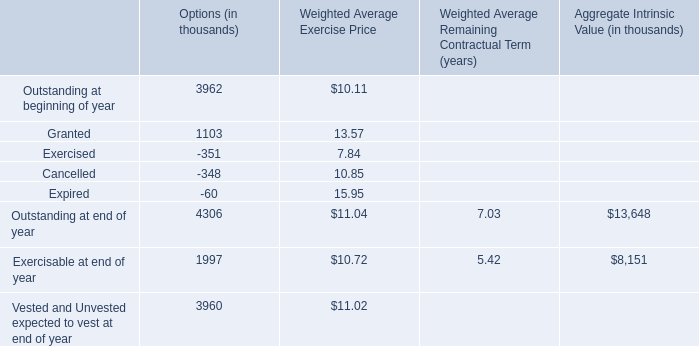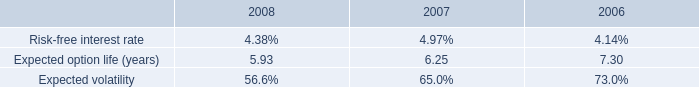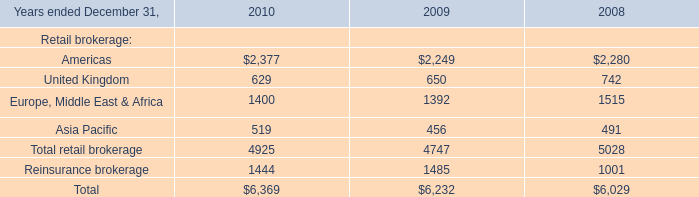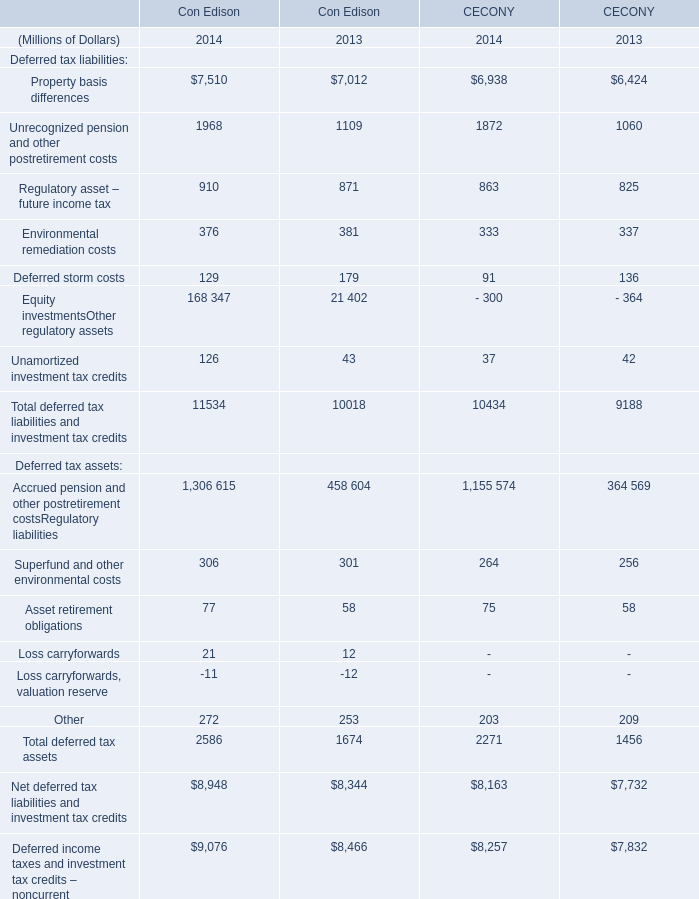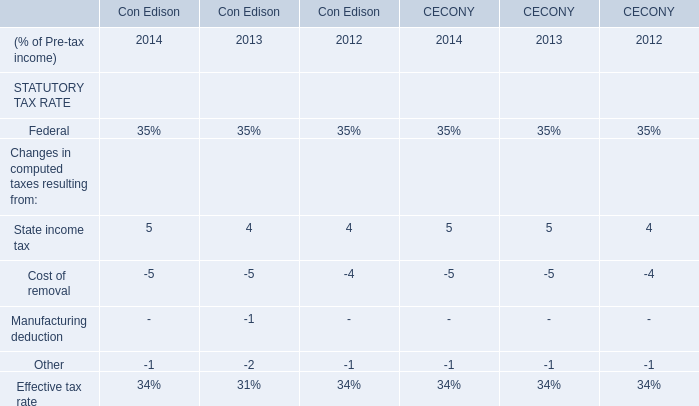What's the current growth rate of Asset retirement obligations in terms of Con Edison? 
Computations: ((77 - 58) / 58)
Answer: 0.32759. 